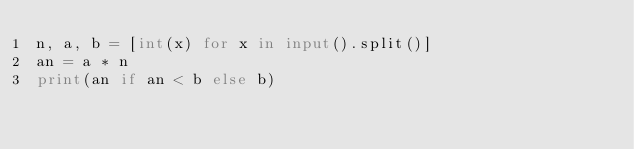Convert code to text. <code><loc_0><loc_0><loc_500><loc_500><_Python_>n, a, b = [int(x) for x in input().split()]
an = a * n
print(an if an < b else b)
</code> 